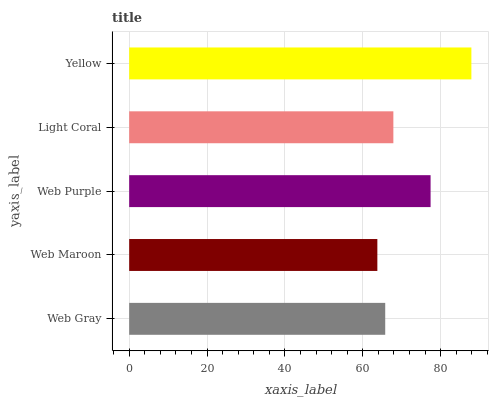Is Web Maroon the minimum?
Answer yes or no. Yes. Is Yellow the maximum?
Answer yes or no. Yes. Is Web Purple the minimum?
Answer yes or no. No. Is Web Purple the maximum?
Answer yes or no. No. Is Web Purple greater than Web Maroon?
Answer yes or no. Yes. Is Web Maroon less than Web Purple?
Answer yes or no. Yes. Is Web Maroon greater than Web Purple?
Answer yes or no. No. Is Web Purple less than Web Maroon?
Answer yes or no. No. Is Light Coral the high median?
Answer yes or no. Yes. Is Light Coral the low median?
Answer yes or no. Yes. Is Web Gray the high median?
Answer yes or no. No. Is Web Purple the low median?
Answer yes or no. No. 